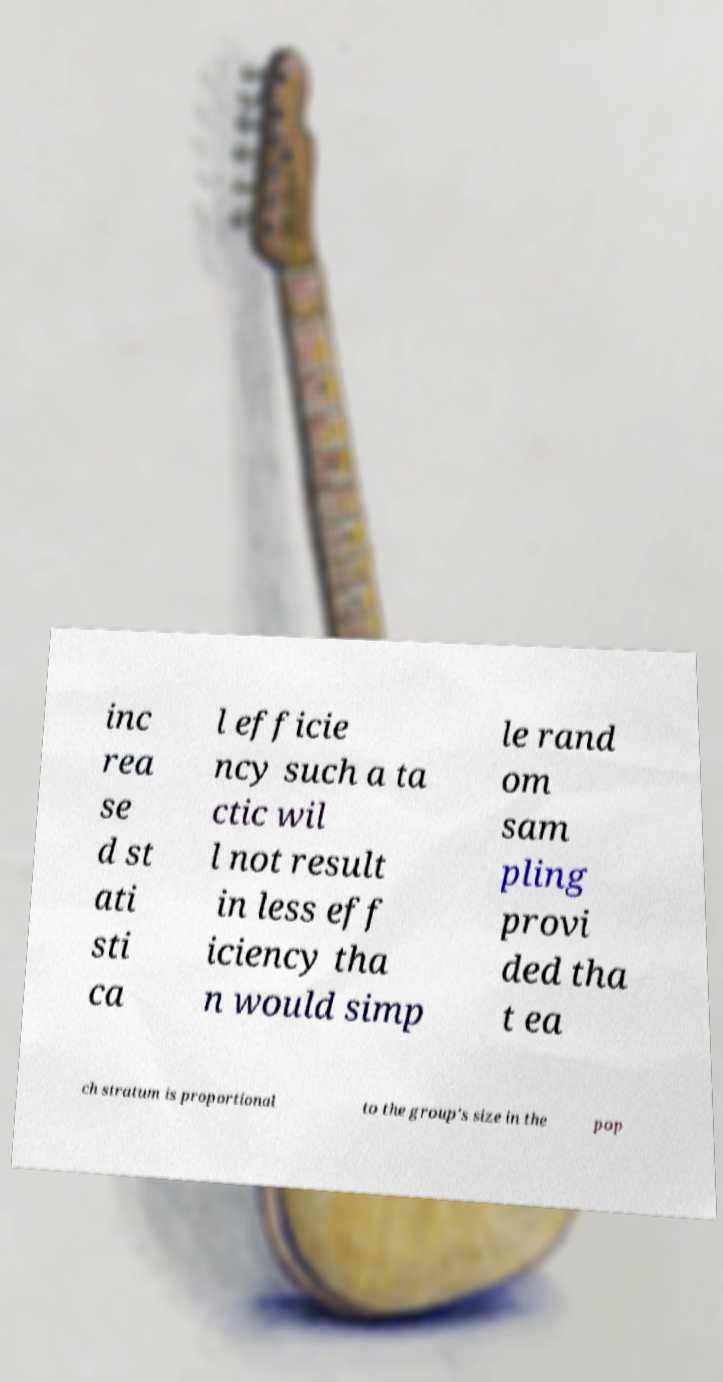Could you assist in decoding the text presented in this image and type it out clearly? inc rea se d st ati sti ca l efficie ncy such a ta ctic wil l not result in less eff iciency tha n would simp le rand om sam pling provi ded tha t ea ch stratum is proportional to the group's size in the pop 